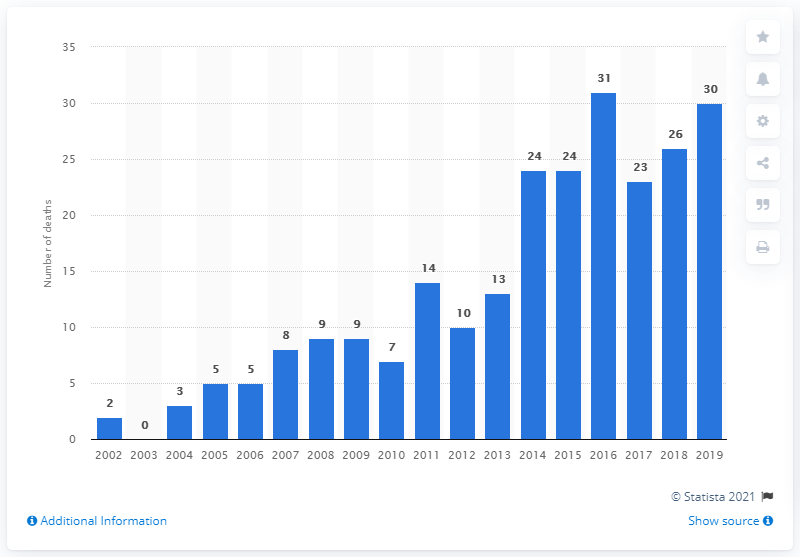Specify some key components in this picture. In 2019, there were 30 deaths resulting from buprenorphine drug poisoning. The number of deaths from buprenorphine drug poisoning in England and Wales reached a peak in 2002. 